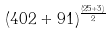<formula> <loc_0><loc_0><loc_500><loc_500>( 4 0 2 + 9 1 ) ^ { \frac { ( 2 5 + 3 ) } { 2 } }</formula> 